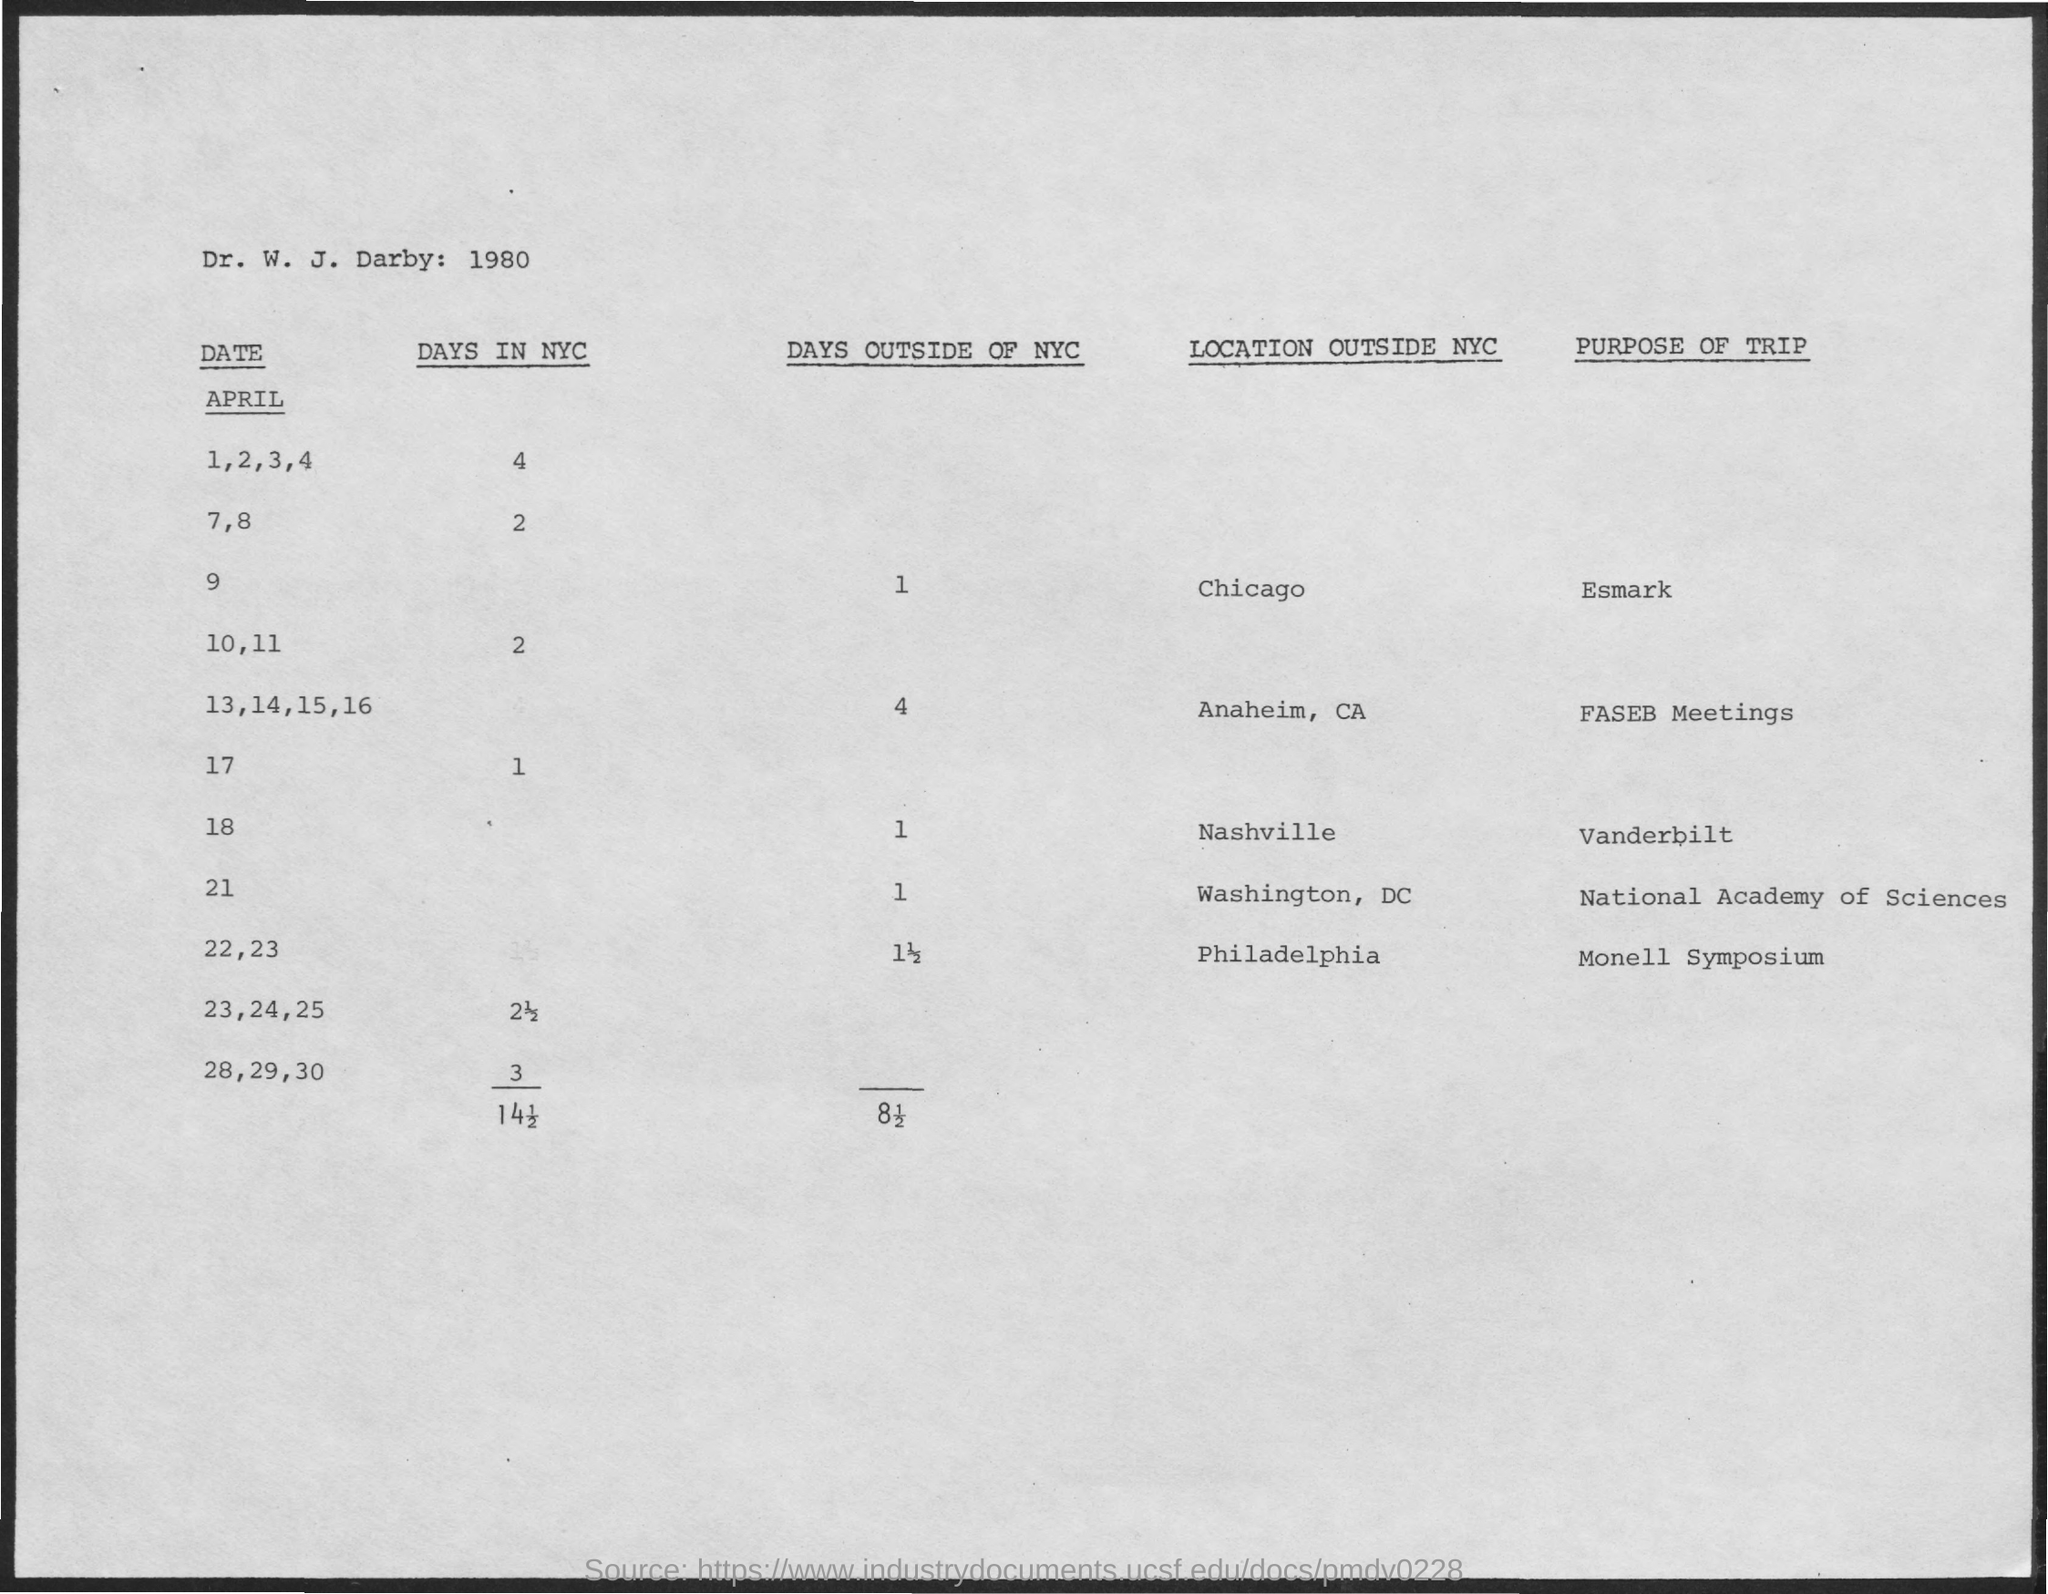Indicate a few pertinent items in this graphic. The Monell Symposium will be held in Philadelphia. On which date in April is the trip to Vanderbilt? April 18th. I am going on a trip to Anaheim, California for the purpose of attending FASEB Meetings. The document mentions the year 1980. 